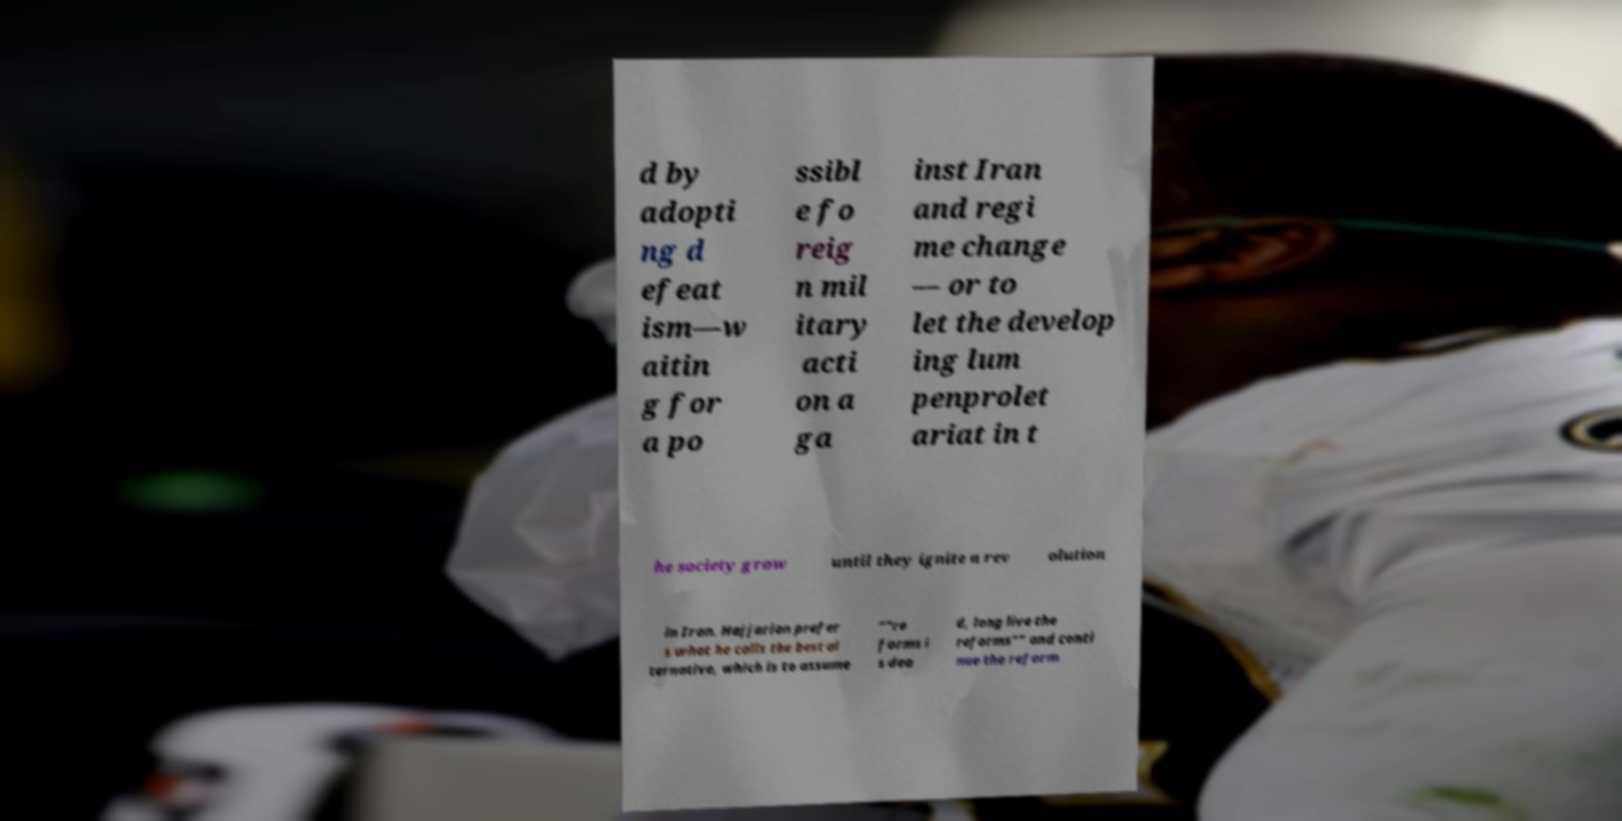Please identify and transcribe the text found in this image. d by adopti ng d efeat ism—w aitin g for a po ssibl e fo reig n mil itary acti on a ga inst Iran and regi me change — or to let the develop ing lum penprolet ariat in t he society grow until they ignite a rev olution in Iran. Hajjarian prefer s what he calls the best al ternative, which is to assume “"re forms i s dea d, long live the reforms"” and conti nue the reform 